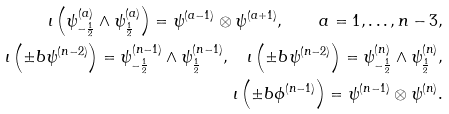Convert formula to latex. <formula><loc_0><loc_0><loc_500><loc_500>\iota \left ( \psi ^ { ( a ) } _ { - \frac { 1 } { 2 } } \wedge \psi ^ { ( a ) } _ { \frac { 1 } { 2 } } \right ) = \psi ^ { ( a - 1 ) } \otimes \psi ^ { ( a + 1 ) } , \quad a = 1 , \dots , n - 3 , \\ \iota \left ( \pm b { \psi } ^ { ( n - 2 ) } \right ) = \psi ^ { ( n - 1 ) } _ { - \frac { 1 } { 2 } } \wedge \psi ^ { ( n - 1 ) } _ { \frac { 1 } { 2 } } , \quad \iota \left ( \pm b { \psi } ^ { ( n - 2 ) } \right ) = \psi ^ { ( n ) } _ { - \frac { 1 } { 2 } } \wedge \psi ^ { ( n ) } _ { \frac { 1 } { 2 } } , \\ \iota \left ( \pm b { \phi } ^ { ( n - 1 ) } \right ) = \psi ^ { ( n - 1 ) } \otimes \psi ^ { ( n ) } .</formula> 